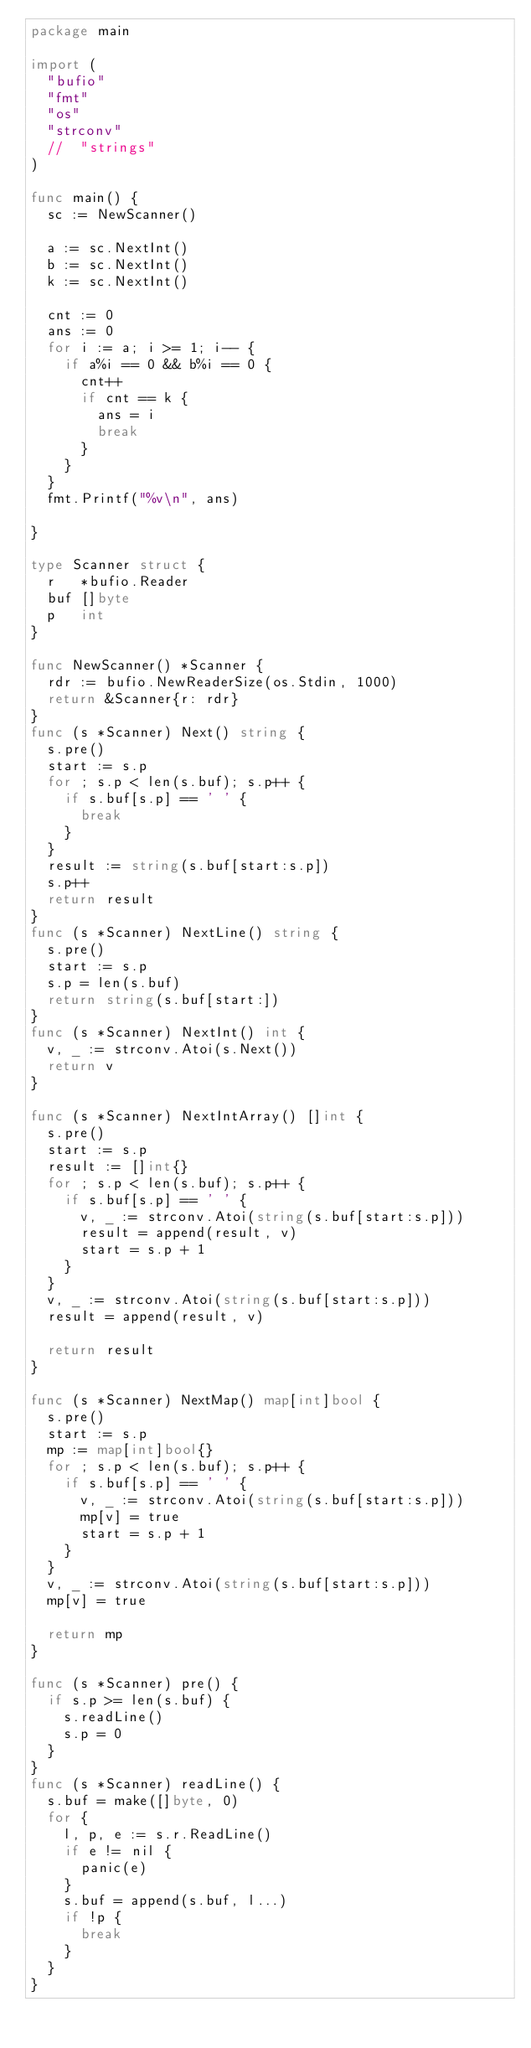Convert code to text. <code><loc_0><loc_0><loc_500><loc_500><_Go_>package main

import (
	"bufio"
	"fmt"
	"os"
	"strconv"
	//	"strings"
)

func main() {
	sc := NewScanner()

	a := sc.NextInt()
	b := sc.NextInt()
	k := sc.NextInt()

	cnt := 0
	ans := 0
	for i := a; i >= 1; i-- {
		if a%i == 0 && b%i == 0 {
			cnt++
			if cnt == k {
				ans = i
				break
			}
		}
	}
	fmt.Printf("%v\n", ans)

}

type Scanner struct {
	r   *bufio.Reader
	buf []byte
	p   int
}

func NewScanner() *Scanner {
	rdr := bufio.NewReaderSize(os.Stdin, 1000)
	return &Scanner{r: rdr}
}
func (s *Scanner) Next() string {
	s.pre()
	start := s.p
	for ; s.p < len(s.buf); s.p++ {
		if s.buf[s.p] == ' ' {
			break
		}
	}
	result := string(s.buf[start:s.p])
	s.p++
	return result
}
func (s *Scanner) NextLine() string {
	s.pre()
	start := s.p
	s.p = len(s.buf)
	return string(s.buf[start:])
}
func (s *Scanner) NextInt() int {
	v, _ := strconv.Atoi(s.Next())
	return v
}

func (s *Scanner) NextIntArray() []int {
	s.pre()
	start := s.p
	result := []int{}
	for ; s.p < len(s.buf); s.p++ {
		if s.buf[s.p] == ' ' {
			v, _ := strconv.Atoi(string(s.buf[start:s.p]))
			result = append(result, v)
			start = s.p + 1
		}
	}
	v, _ := strconv.Atoi(string(s.buf[start:s.p]))
	result = append(result, v)

	return result
}

func (s *Scanner) NextMap() map[int]bool {
	s.pre()
	start := s.p
	mp := map[int]bool{}
	for ; s.p < len(s.buf); s.p++ {
		if s.buf[s.p] == ' ' {
			v, _ := strconv.Atoi(string(s.buf[start:s.p]))
			mp[v] = true
			start = s.p + 1
		}
	}
	v, _ := strconv.Atoi(string(s.buf[start:s.p]))
	mp[v] = true

	return mp
}

func (s *Scanner) pre() {
	if s.p >= len(s.buf) {
		s.readLine()
		s.p = 0
	}
}
func (s *Scanner) readLine() {
	s.buf = make([]byte, 0)
	for {
		l, p, e := s.r.ReadLine()
		if e != nil {
			panic(e)
		}
		s.buf = append(s.buf, l...)
		if !p {
			break
		}
	}
}
</code> 